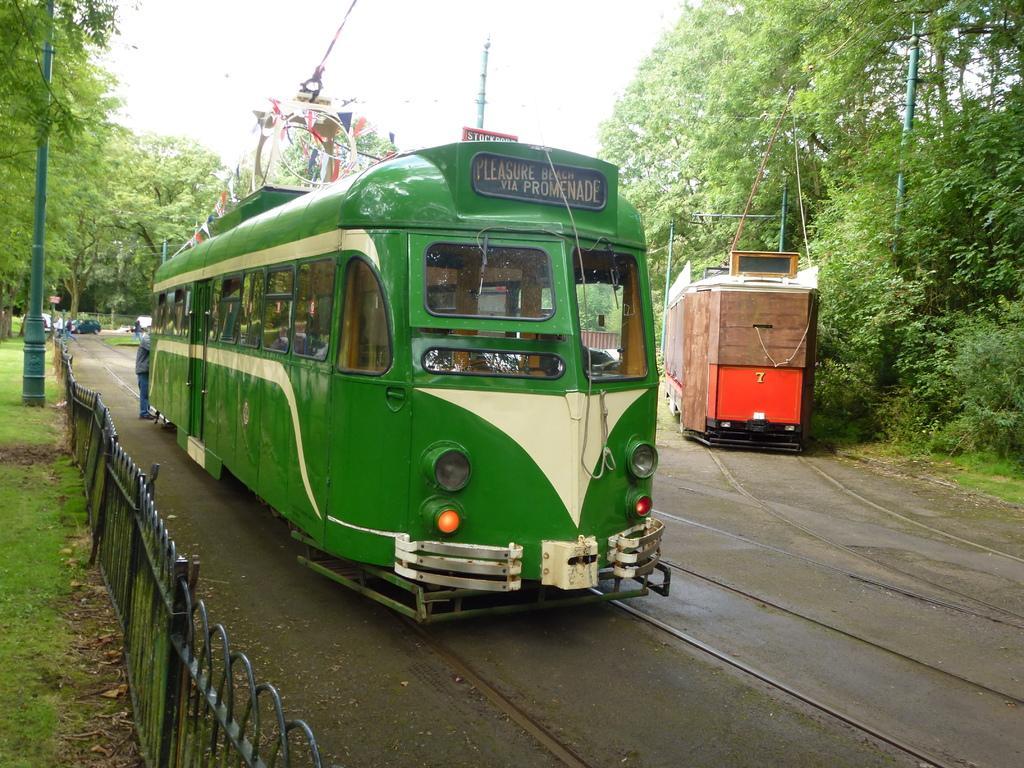In one or two sentences, can you explain what this image depicts? In this picture I can see couple of metro rails on the tracks and I can see human standing and I can see few cars and trees and I can see poles and a metal fence and I can see a cloudy sky. 